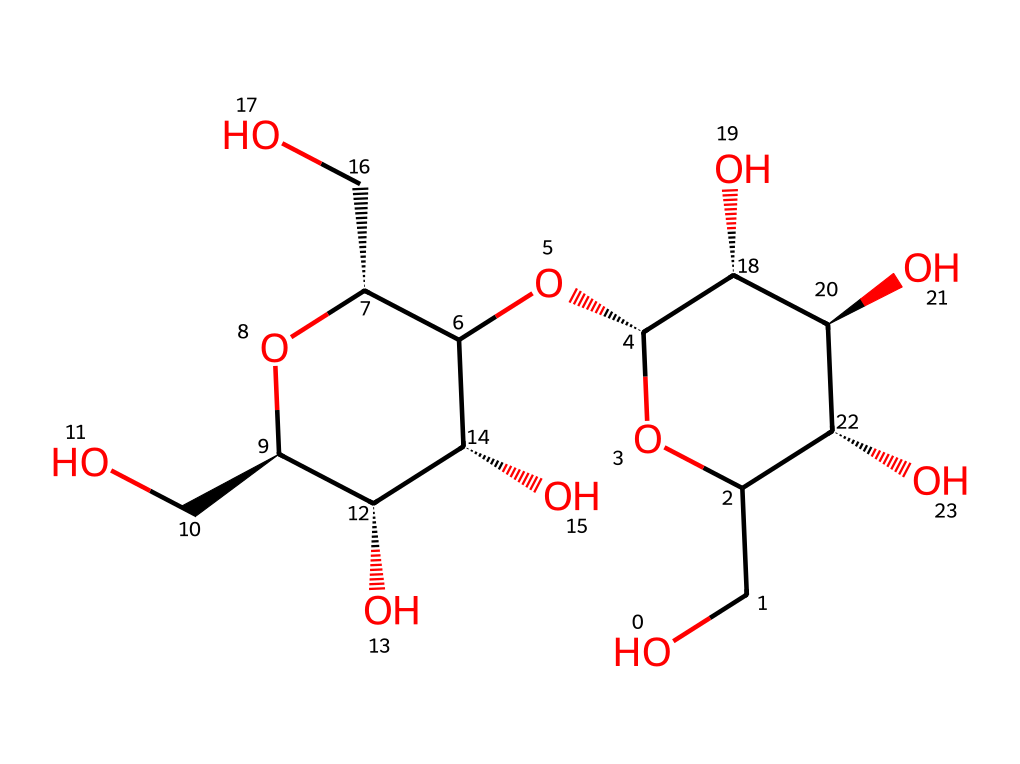What is the primary component of this chemical structure? The chemical structure represents cellulose, which is a polysaccharide made of glucose units and serves as the primary component of paper.
Answer: cellulose How many oxygen atoms are present in this structure? By examining the SMILES representation, there are six oxygen atoms present in the backbone of cellulose, connecting the various carbon atoms.
Answer: six What type of macromolecule is represented by this chemical structure? This structure is a polysaccharide, specifically a carbohydrate, composed of multiple sugar (glucose) units linked together to form a larger molecule.
Answer: polysaccharide Does this structure contain any branching? Analyzing the connections between the carbon atoms, cellulose is generally linear without branches, showing a straight-chain formation typical for cellulose.
Answer: no How many ring structures are in this chemical? The structure contains two ring forms which are characteristic of glucose, as cellulose is made up of repeating glucose units, which often arrange in cyclic forms.
Answer: two What functional groups are presented in the structure? The structure features hydroxyl (-OH) functional groups, which are indicated in the SMILES representation and contribute to the properties of cellulose such as hydrogen bonding.
Answer: hydroxyl groups What is the stereochemistry of this chemical structure? The chemical structure has stereocenters at several carbon atoms, indicated by the '@' symbol in the SMILES notation, suggesting that there are multiple stereoisomers associated with cellulose.
Answer: chiral 